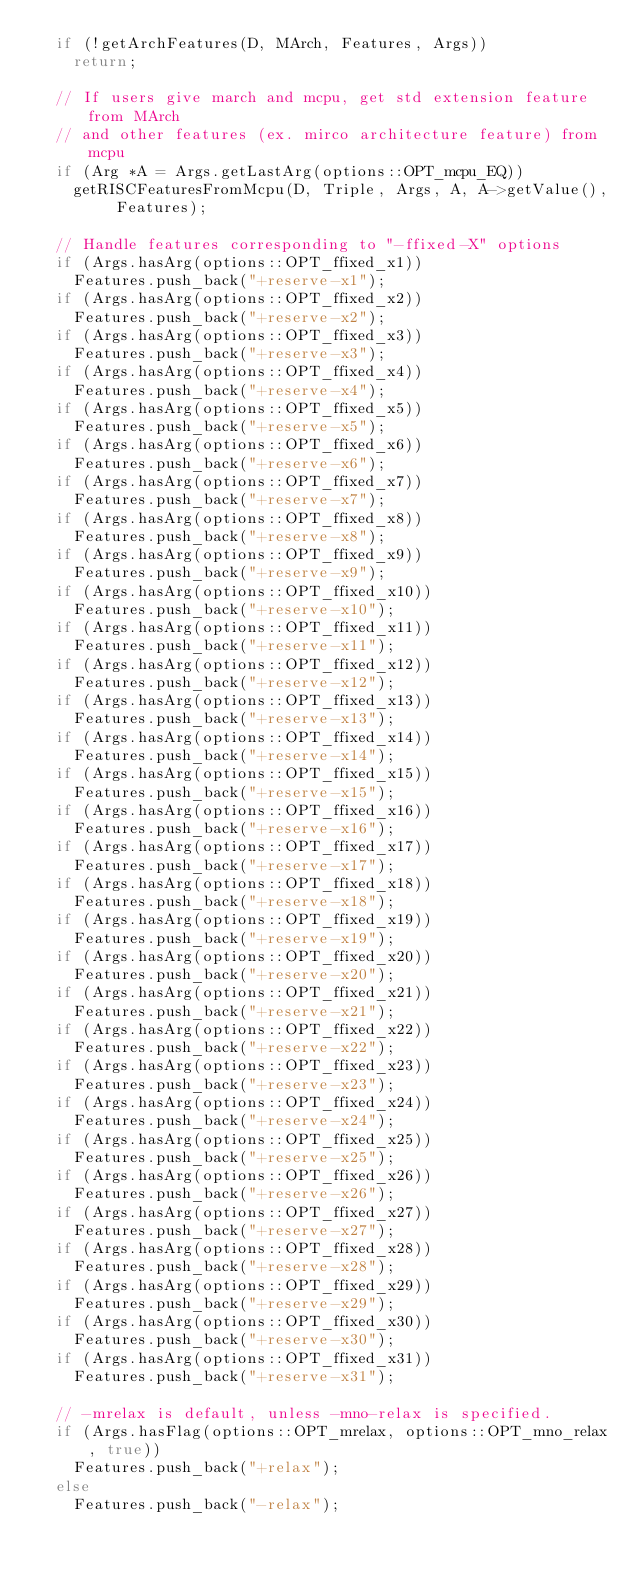Convert code to text. <code><loc_0><loc_0><loc_500><loc_500><_C++_>  if (!getArchFeatures(D, MArch, Features, Args))
    return;

  // If users give march and mcpu, get std extension feature from MArch
  // and other features (ex. mirco architecture feature) from mcpu
  if (Arg *A = Args.getLastArg(options::OPT_mcpu_EQ))
    getRISCFeaturesFromMcpu(D, Triple, Args, A, A->getValue(), Features);

  // Handle features corresponding to "-ffixed-X" options
  if (Args.hasArg(options::OPT_ffixed_x1))
    Features.push_back("+reserve-x1");
  if (Args.hasArg(options::OPT_ffixed_x2))
    Features.push_back("+reserve-x2");
  if (Args.hasArg(options::OPT_ffixed_x3))
    Features.push_back("+reserve-x3");
  if (Args.hasArg(options::OPT_ffixed_x4))
    Features.push_back("+reserve-x4");
  if (Args.hasArg(options::OPT_ffixed_x5))
    Features.push_back("+reserve-x5");
  if (Args.hasArg(options::OPT_ffixed_x6))
    Features.push_back("+reserve-x6");
  if (Args.hasArg(options::OPT_ffixed_x7))
    Features.push_back("+reserve-x7");
  if (Args.hasArg(options::OPT_ffixed_x8))
    Features.push_back("+reserve-x8");
  if (Args.hasArg(options::OPT_ffixed_x9))
    Features.push_back("+reserve-x9");
  if (Args.hasArg(options::OPT_ffixed_x10))
    Features.push_back("+reserve-x10");
  if (Args.hasArg(options::OPT_ffixed_x11))
    Features.push_back("+reserve-x11");
  if (Args.hasArg(options::OPT_ffixed_x12))
    Features.push_back("+reserve-x12");
  if (Args.hasArg(options::OPT_ffixed_x13))
    Features.push_back("+reserve-x13");
  if (Args.hasArg(options::OPT_ffixed_x14))
    Features.push_back("+reserve-x14");
  if (Args.hasArg(options::OPT_ffixed_x15))
    Features.push_back("+reserve-x15");
  if (Args.hasArg(options::OPT_ffixed_x16))
    Features.push_back("+reserve-x16");
  if (Args.hasArg(options::OPT_ffixed_x17))
    Features.push_back("+reserve-x17");
  if (Args.hasArg(options::OPT_ffixed_x18))
    Features.push_back("+reserve-x18");
  if (Args.hasArg(options::OPT_ffixed_x19))
    Features.push_back("+reserve-x19");
  if (Args.hasArg(options::OPT_ffixed_x20))
    Features.push_back("+reserve-x20");
  if (Args.hasArg(options::OPT_ffixed_x21))
    Features.push_back("+reserve-x21");
  if (Args.hasArg(options::OPT_ffixed_x22))
    Features.push_back("+reserve-x22");
  if (Args.hasArg(options::OPT_ffixed_x23))
    Features.push_back("+reserve-x23");
  if (Args.hasArg(options::OPT_ffixed_x24))
    Features.push_back("+reserve-x24");
  if (Args.hasArg(options::OPT_ffixed_x25))
    Features.push_back("+reserve-x25");
  if (Args.hasArg(options::OPT_ffixed_x26))
    Features.push_back("+reserve-x26");
  if (Args.hasArg(options::OPT_ffixed_x27))
    Features.push_back("+reserve-x27");
  if (Args.hasArg(options::OPT_ffixed_x28))
    Features.push_back("+reserve-x28");
  if (Args.hasArg(options::OPT_ffixed_x29))
    Features.push_back("+reserve-x29");
  if (Args.hasArg(options::OPT_ffixed_x30))
    Features.push_back("+reserve-x30");
  if (Args.hasArg(options::OPT_ffixed_x31))
    Features.push_back("+reserve-x31");

  // -mrelax is default, unless -mno-relax is specified.
  if (Args.hasFlag(options::OPT_mrelax, options::OPT_mno_relax, true))
    Features.push_back("+relax");
  else
    Features.push_back("-relax");
</code> 